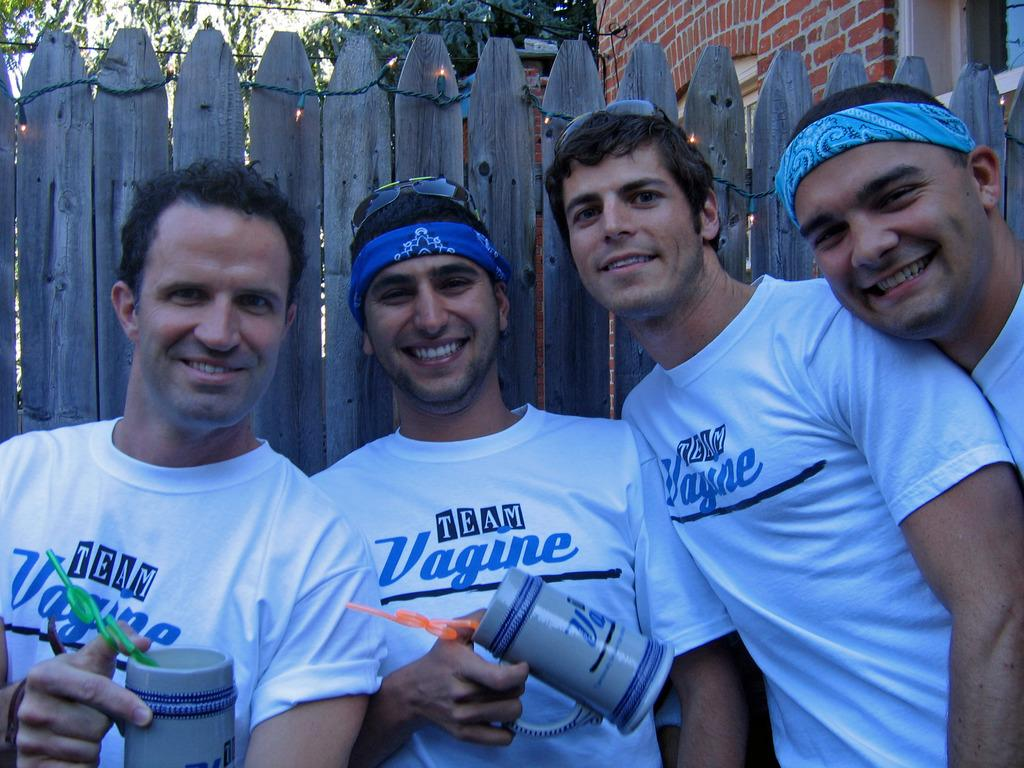<image>
Share a concise interpretation of the image provided. a few guys with the word vagune on their shirts 